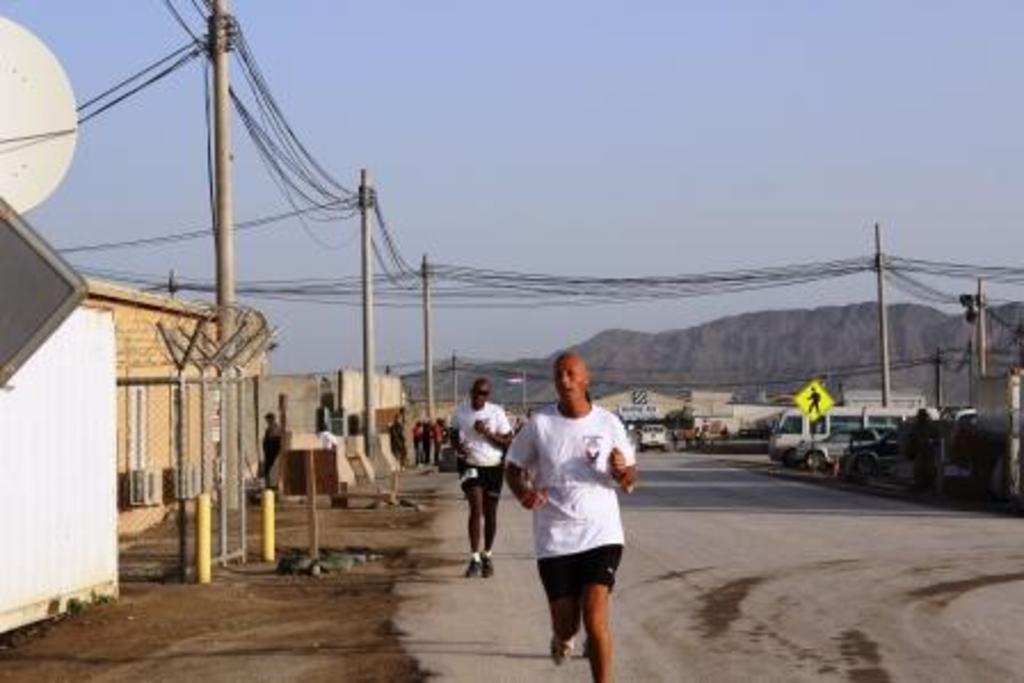In one or two sentences, can you explain what this image depicts? This image is taken outdoors. At the top of the image there is the sky. At the bottom of the image there is a road. In the background there are few hills and there are a few houses. A few vehicles are parked on the road. On the left side of the image there are few houses with walls, windows, doors and rooms. There are a few poles with wires. A few people are standing on the ground. There is a sign board. In the middle of the image two men are running on the road. On the right side of the image a few vehicles are parked on the road. There are a few poles with wires and there is a sign board. 